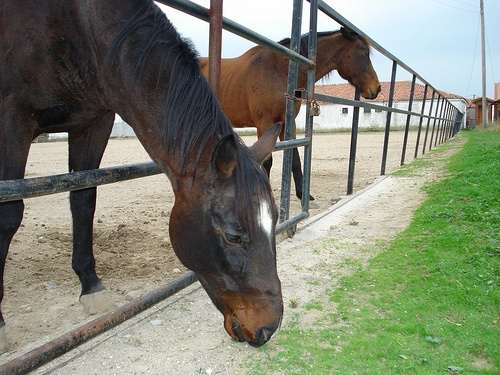Describe the objects in this image and their specific colors. I can see horse in black and gray tones and horse in black, maroon, and gray tones in this image. 